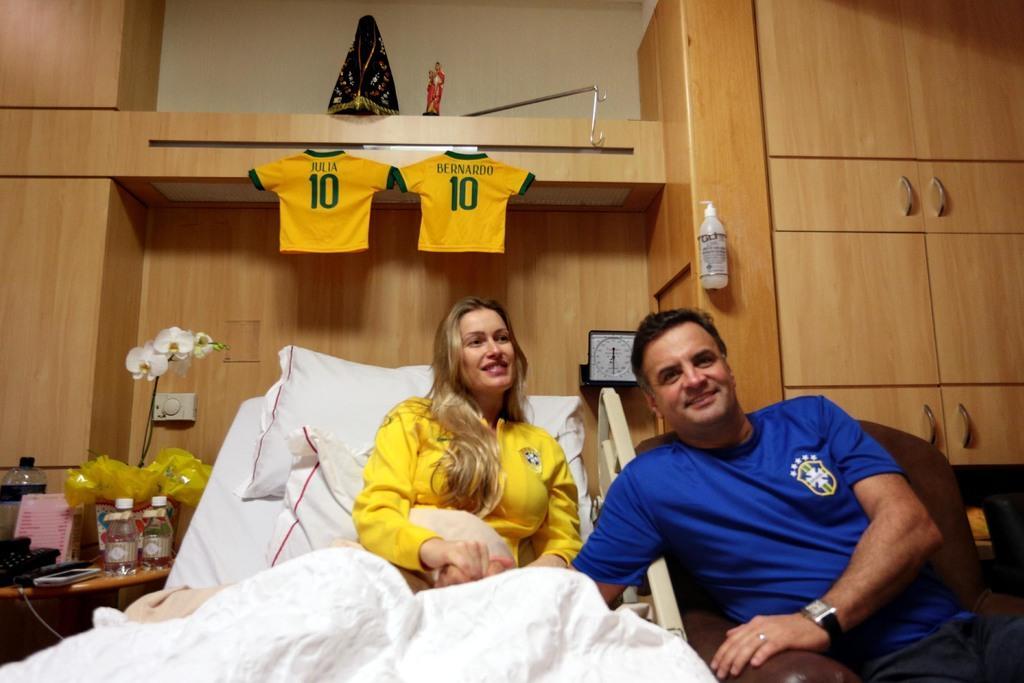In one or two sentences, can you explain what this image depicts? In this image i can see a woman wearing a yellow dress lying on the bed, on the bed i can see 2 pillows and a bed sheet. I can see a man sitting on the couch beside the bed wearing a watch and blue t shirt. In the background i can see few bottles, a telephone, a mobile, a flower, 2 t shirts and the wall. 